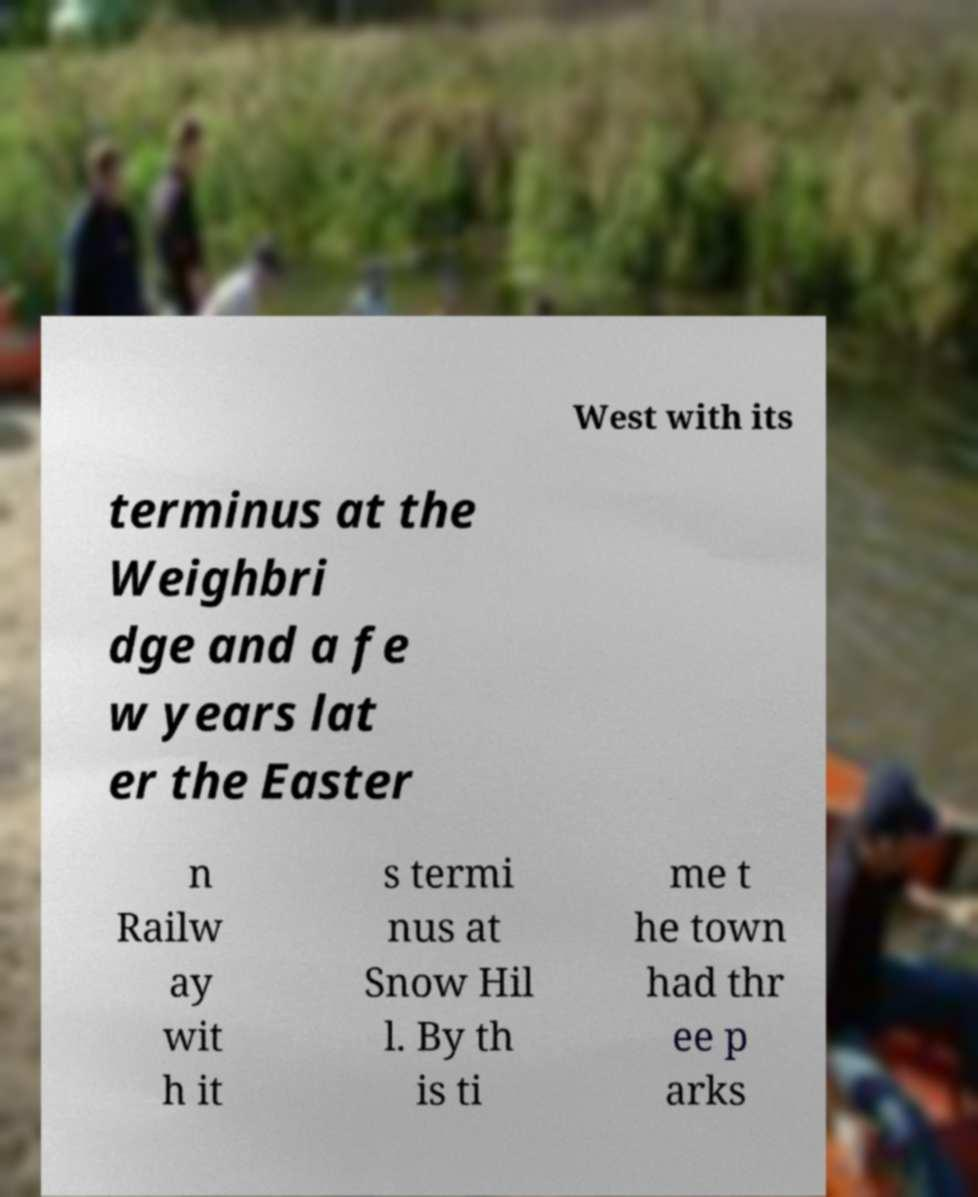Please identify and transcribe the text found in this image. West with its terminus at the Weighbri dge and a fe w years lat er the Easter n Railw ay wit h it s termi nus at Snow Hil l. By th is ti me t he town had thr ee p arks 